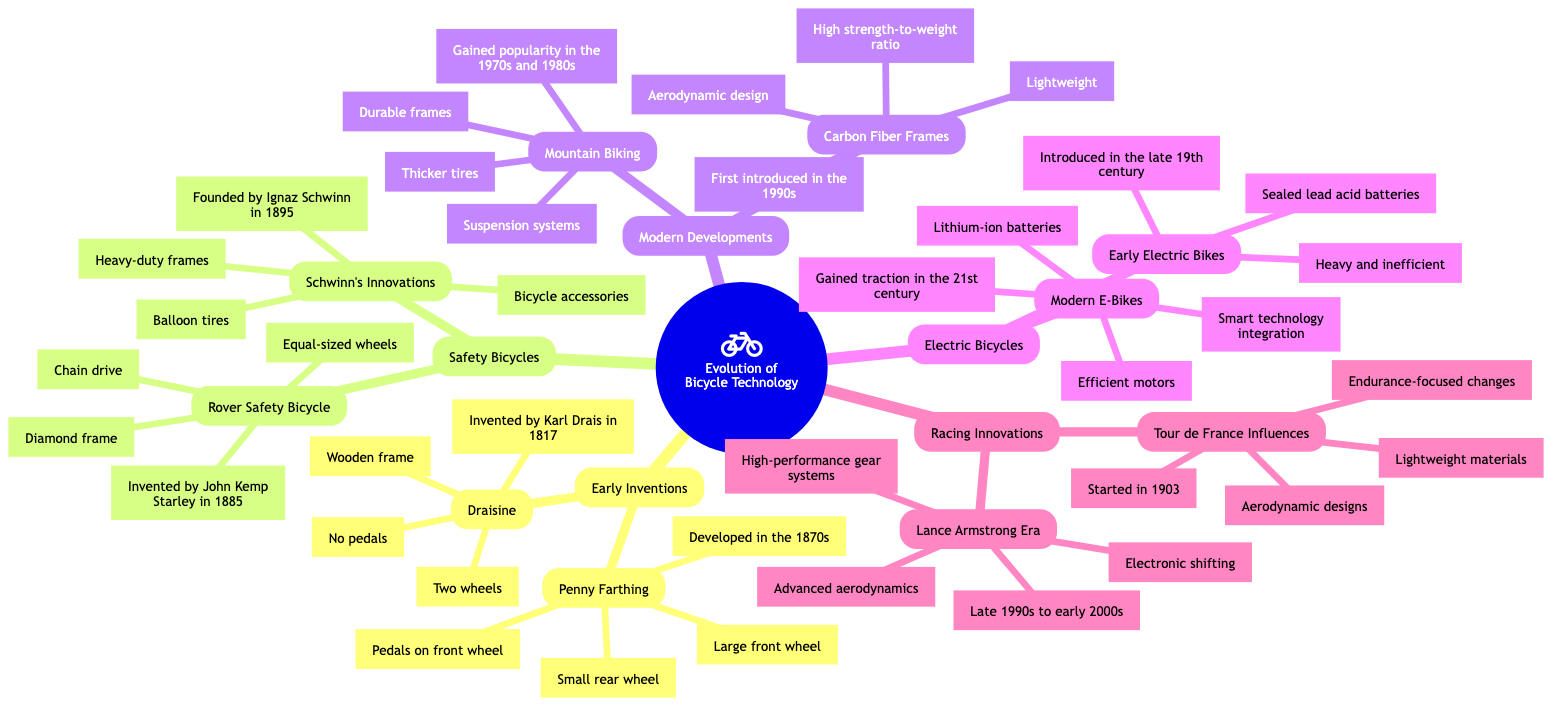What is the central node of the diagram? The central node is labeled as "Evolution of Bicycle Technology," representing the main theme of the mind map.
Answer: Evolution of Bicycle Technology How many branches are there in the diagram? There are five main branches originating from the central node: Early Inventions, Safety Bicycles, Modern Developments, Electric Bicycles, and Racing Innovations.
Answer: 5 Which bicycle was invented by Karl Drais? The sub-branch "Draisine" refers to the bicycle invented by Karl Drais in 1817, as indicated in the descriptive information.
Answer: Draisine What feature distinguishes the Penny Farthing from other bicycles? The Penny Farthing is distinguished by its "Large front wheel," which is a unique characteristic compared to other types of bicycles noted in the diagram.
Answer: Large front wheel Who founded Schwinn’s Innovations? The information under "Schwinn's Innovations" indicates that it was founded by Ignaz Schwinn in 1895.
Answer: Ignaz Schwinn What year did the Rover Safety Bicycle get invented? According to the diagram, the Rover Safety Bicycle was invented in 1885, as described in the relevant sub-branch.
Answer: 1885 Which development gained popularity in the 1970s and 1980s? The "Mountain Biking" sub-branch mentions that this type of cycling gained popularity during the 1970s and 1980s.
Answer: Mountain Biking What feature was first introduced in the 1990s? The sub-branch "Carbon Fiber Frames" states that this innovation was first introduced in the 1990s, highlighting a significant shift in bicycle technology.
Answer: Carbon Fiber Frames What significant technology did Modern E-Bikes incorporate? The description of "Modern E-Bikes" indicates that they incorporated "Smart technology integration," setting them apart from earlier electric bikes.
Answer: Smart technology integration What innovations influenced the racing bicycles since 1903? The "Tour de France Influences" sub-branch notes that lightweight materials and aerodynamic designs have influenced racing bicycles since 1903.
Answer: Lightweight materials and aerodynamic designs 